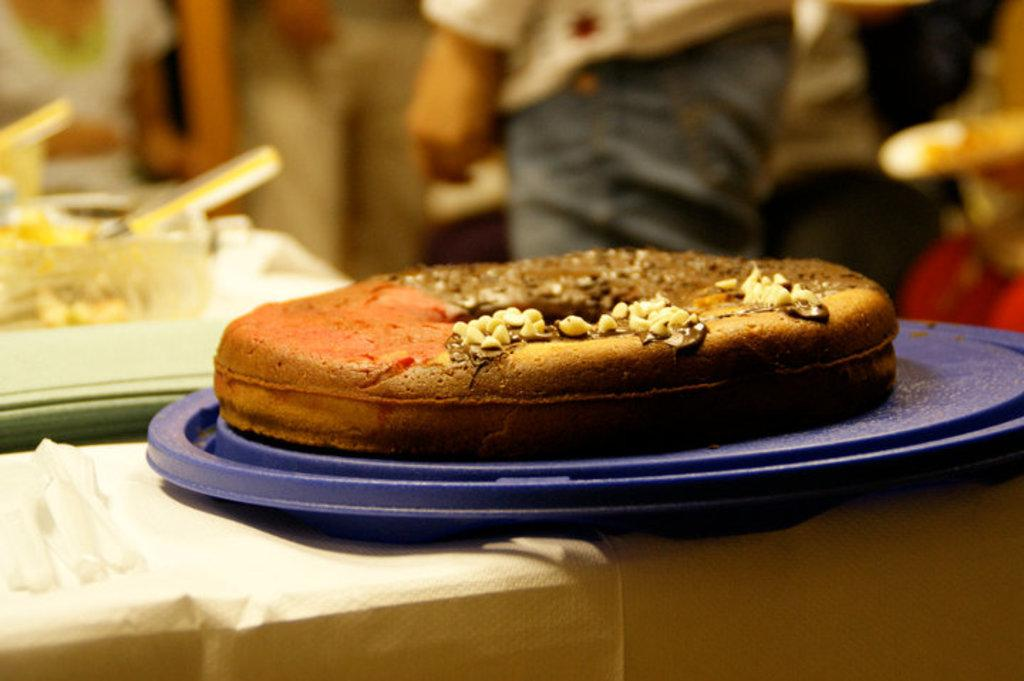What is the main subject of the image? There is a food item on a plate on a platform in the image. Can you describe the background of the image? The background of the image is blurred, but objects are visible. Are there any people in the image? Few persons are present in the background. What type of rabbit can be seen in the history book in the image? There is no rabbit or history book present in the image. What is the maid doing in the image? There is no maid present in the image. 